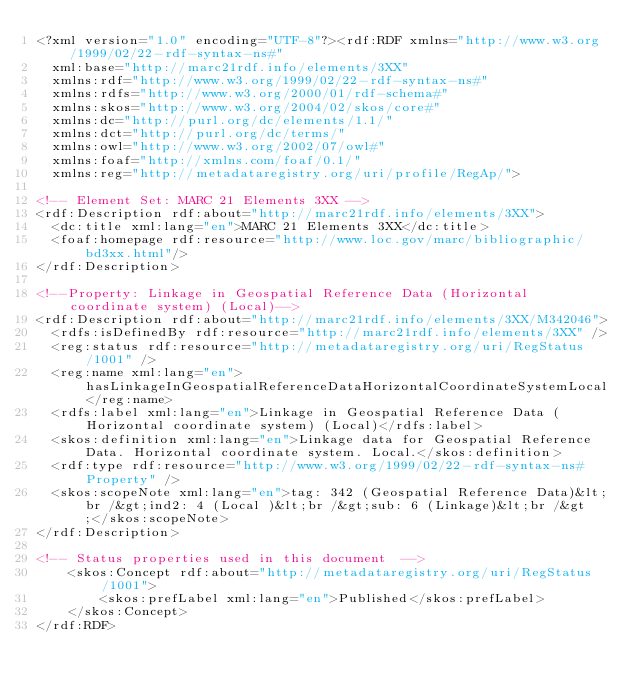<code> <loc_0><loc_0><loc_500><loc_500><_XML_><?xml version="1.0" encoding="UTF-8"?><rdf:RDF xmlns="http://www.w3.org/1999/02/22-rdf-syntax-ns#"
  xml:base="http://marc21rdf.info/elements/3XX"
  xmlns:rdf="http://www.w3.org/1999/02/22-rdf-syntax-ns#"
  xmlns:rdfs="http://www.w3.org/2000/01/rdf-schema#"
  xmlns:skos="http://www.w3.org/2004/02/skos/core#"
  xmlns:dc="http://purl.org/dc/elements/1.1/"
  xmlns:dct="http://purl.org/dc/terms/"
  xmlns:owl="http://www.w3.org/2002/07/owl#"
  xmlns:foaf="http://xmlns.com/foaf/0.1/"
  xmlns:reg="http://metadataregistry.org/uri/profile/RegAp/">

<!-- Element Set: MARC 21 Elements 3XX -->
<rdf:Description rdf:about="http://marc21rdf.info/elements/3XX">
  <dc:title xml:lang="en">MARC 21 Elements 3XX</dc:title>
  <foaf:homepage rdf:resource="http://www.loc.gov/marc/bibliographic/bd3xx.html"/>
</rdf:Description>

<!--Property: Linkage in Geospatial Reference Data (Horizontal coordinate system) (Local)-->
<rdf:Description rdf:about="http://marc21rdf.info/elements/3XX/M342046">
  <rdfs:isDefinedBy rdf:resource="http://marc21rdf.info/elements/3XX" />
  <reg:status rdf:resource="http://metadataregistry.org/uri/RegStatus/1001" />
  <reg:name xml:lang="en">hasLinkageInGeospatialReferenceDataHorizontalCoordinateSystemLocal</reg:name>
  <rdfs:label xml:lang="en">Linkage in Geospatial Reference Data (Horizontal coordinate system) (Local)</rdfs:label>
  <skos:definition xml:lang="en">Linkage data for Geospatial Reference Data. Horizontal coordinate system. Local.</skos:definition>
  <rdf:type rdf:resource="http://www.w3.org/1999/02/22-rdf-syntax-ns#Property" />
  <skos:scopeNote xml:lang="en">tag: 342 (Geospatial Reference Data)&lt;br /&gt;ind2: 4 (Local )&lt;br /&gt;sub: 6 (Linkage)&lt;br /&gt;</skos:scopeNote>
</rdf:Description>

<!-- Status properties used in this document  -->
    <skos:Concept rdf:about="http://metadataregistry.org/uri/RegStatus/1001">
        <skos:prefLabel xml:lang="en">Published</skos:prefLabel>
    </skos:Concept>
</rdf:RDF></code> 